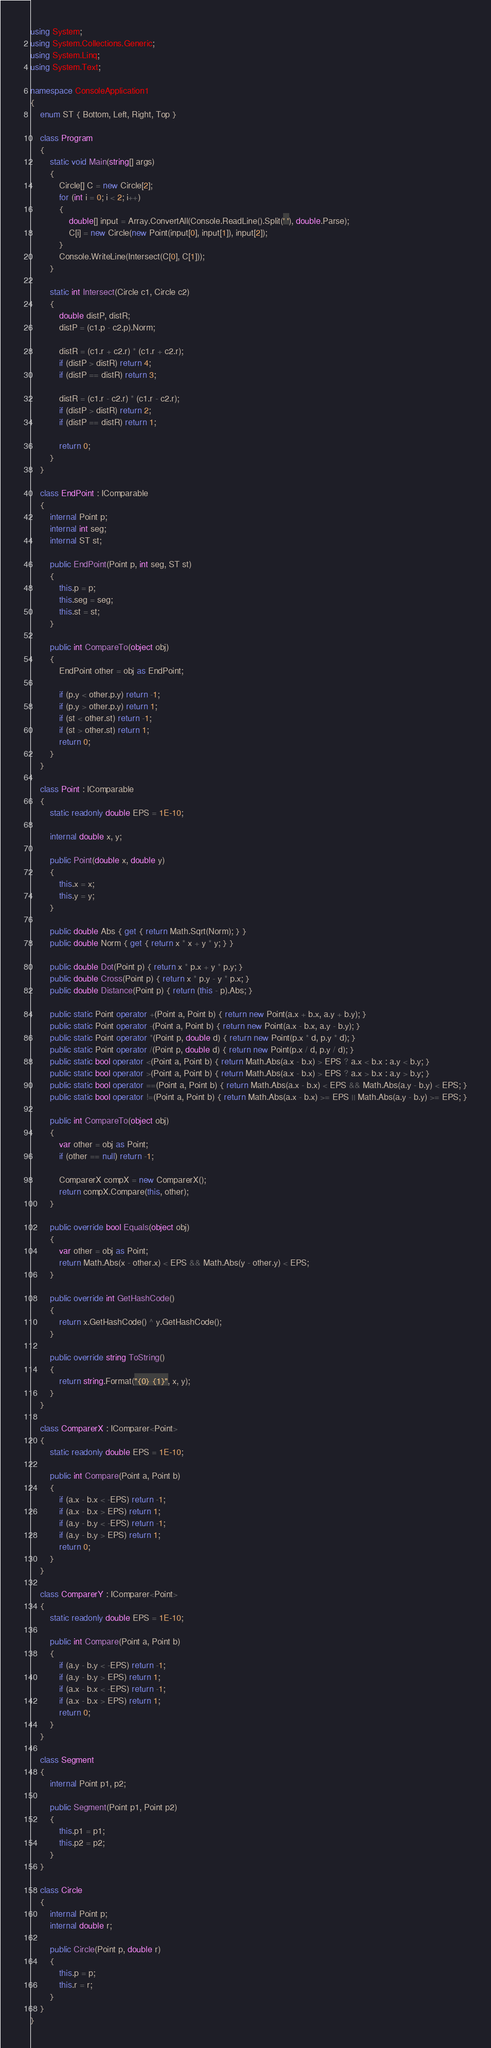Convert code to text. <code><loc_0><loc_0><loc_500><loc_500><_C#_>using System;
using System.Collections.Generic;
using System.Linq;
using System.Text;

namespace ConsoleApplication1
{
    enum ST { Bottom, Left, Right, Top }

    class Program
    {
        static void Main(string[] args)
        {
            Circle[] C = new Circle[2];
            for (int i = 0; i < 2; i++)
            {
                double[] input = Array.ConvertAll(Console.ReadLine().Split(' '), double.Parse);
                C[i] = new Circle(new Point(input[0], input[1]), input[2]);
            }
            Console.WriteLine(Intersect(C[0], C[1]));
        }

        static int Intersect(Circle c1, Circle c2)
        {
            double distP, distR;
            distP = (c1.p - c2.p).Norm;

            distR = (c1.r + c2.r) * (c1.r + c2.r);
            if (distP > distR) return 4;
            if (distP == distR) return 3;

            distR = (c1.r - c2.r) * (c1.r - c2.r);
            if (distP > distR) return 2;
            if (distP == distR) return 1;

            return 0;
        }
    }

    class EndPoint : IComparable
    {
        internal Point p;
        internal int seg;
        internal ST st;

        public EndPoint(Point p, int seg, ST st)
        {
            this.p = p;
            this.seg = seg;
            this.st = st;
        }

        public int CompareTo(object obj)
        {
            EndPoint other = obj as EndPoint;

            if (p.y < other.p.y) return -1;
            if (p.y > other.p.y) return 1;
            if (st < other.st) return -1;
            if (st > other.st) return 1;
            return 0;
        }
    }

    class Point : IComparable
    {
        static readonly double EPS = 1E-10;

        internal double x, y;

        public Point(double x, double y)
        {
            this.x = x;
            this.y = y;
        }

        public double Abs { get { return Math.Sqrt(Norm); } }
        public double Norm { get { return x * x + y * y; } }

        public double Dot(Point p) { return x * p.x + y * p.y; }
        public double Cross(Point p) { return x * p.y - y * p.x; }
        public double Distance(Point p) { return (this - p).Abs; }

        public static Point operator +(Point a, Point b) { return new Point(a.x + b.x, a.y + b.y); }
        public static Point operator -(Point a, Point b) { return new Point(a.x - b.x, a.y - b.y); }
        public static Point operator *(Point p, double d) { return new Point(p.x * d, p.y * d); }
        public static Point operator /(Point p, double d) { return new Point(p.x / d, p.y / d); }
        public static bool operator <(Point a, Point b) { return Math.Abs(a.x - b.x) > EPS ? a.x < b.x : a.y < b.y; }
        public static bool operator >(Point a, Point b) { return Math.Abs(a.x - b.x) > EPS ? a.x > b.x : a.y > b.y; }
        public static bool operator ==(Point a, Point b) { return Math.Abs(a.x - b.x) < EPS && Math.Abs(a.y - b.y) < EPS; }
        public static bool operator !=(Point a, Point b) { return Math.Abs(a.x - b.x) >= EPS || Math.Abs(a.y - b.y) >= EPS; }

        public int CompareTo(object obj)
        {
            var other = obj as Point;
            if (other == null) return -1;

            ComparerX compX = new ComparerX();
            return compX.Compare(this, other);
        }

        public override bool Equals(object obj)
        {
            var other = obj as Point;
            return Math.Abs(x - other.x) < EPS && Math.Abs(y - other.y) < EPS;
        }

        public override int GetHashCode()
        {
            return x.GetHashCode() ^ y.GetHashCode();
        }

        public override string ToString()
        {
            return string.Format("{0} {1}", x, y);
        }
    }

    class ComparerX : IComparer<Point>
    {
        static readonly double EPS = 1E-10;

        public int Compare(Point a, Point b)
        {
            if (a.x - b.x < -EPS) return -1;
            if (a.x - b.x > EPS) return 1;
            if (a.y - b.y < -EPS) return -1;
            if (a.y - b.y > EPS) return 1;
            return 0;
        }
    }

    class ComparerY : IComparer<Point>
    {
        static readonly double EPS = 1E-10;

        public int Compare(Point a, Point b)
        {
            if (a.y - b.y < -EPS) return -1;
            if (a.y - b.y > EPS) return 1;
            if (a.x - b.x < -EPS) return -1;
            if (a.x - b.x > EPS) return 1;
            return 0;
        }
    }

    class Segment
    {
        internal Point p1, p2;

        public Segment(Point p1, Point p2)
        {
            this.p1 = p1;
            this.p2 = p2;
        }
    }

    class Circle
    {
        internal Point p;
        internal double r;

        public Circle(Point p, double r)
        {
            this.p = p;
            this.r = r;
        }
    }
}</code> 